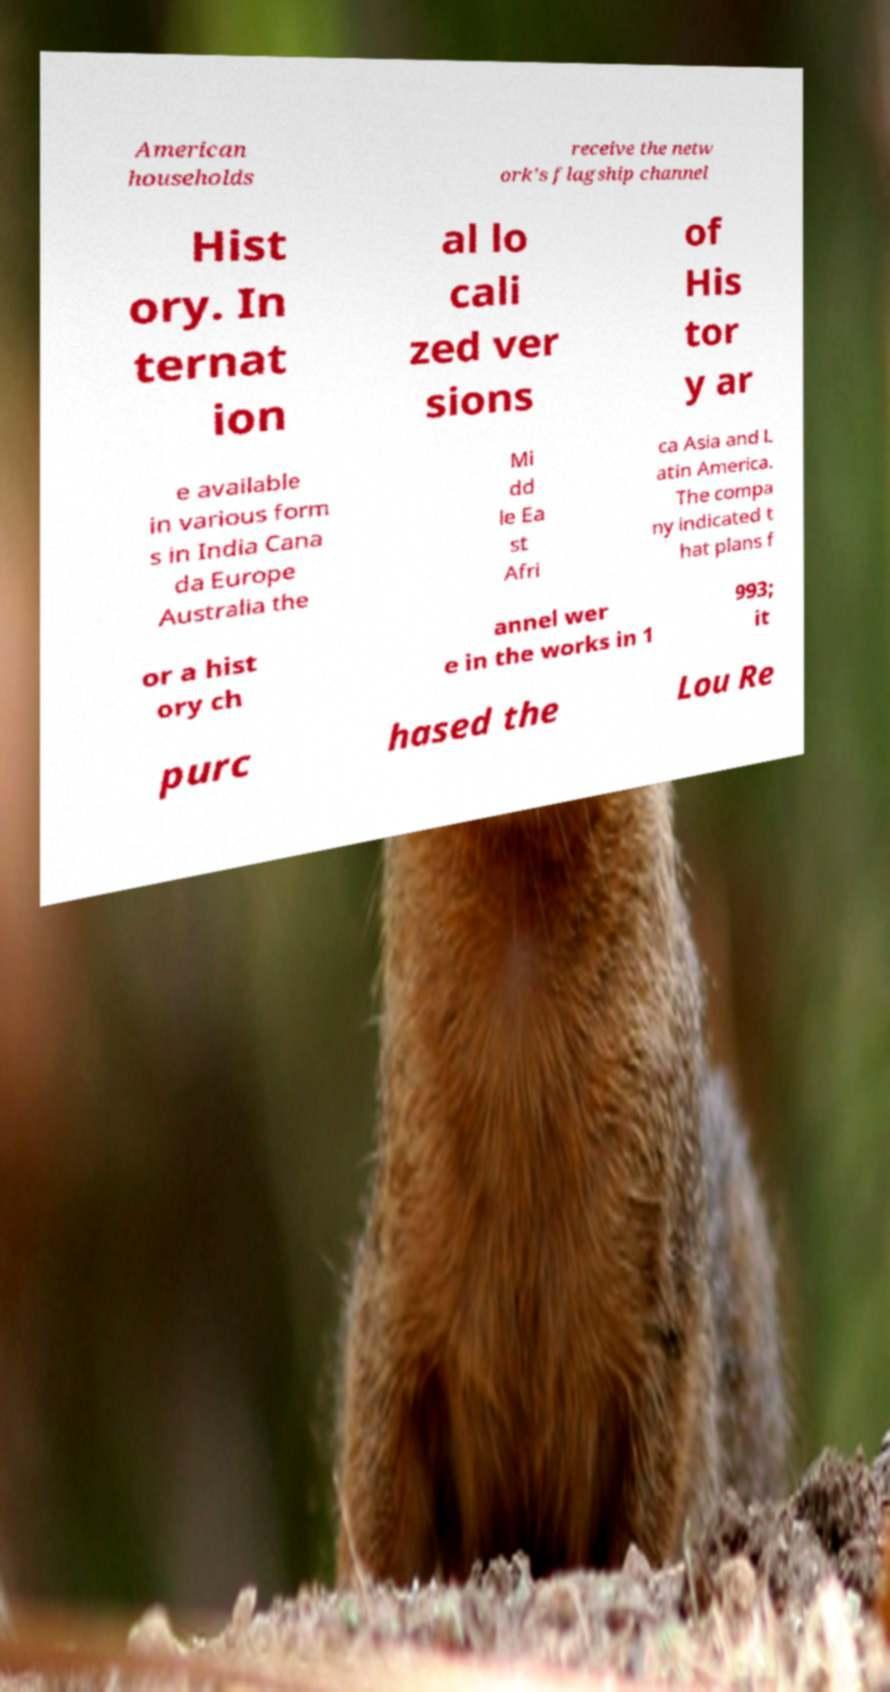Please identify and transcribe the text found in this image. American households receive the netw ork's flagship channel Hist ory. In ternat ion al lo cali zed ver sions of His tor y ar e available in various form s in India Cana da Europe Australia the Mi dd le Ea st Afri ca Asia and L atin America. The compa ny indicated t hat plans f or a hist ory ch annel wer e in the works in 1 993; it purc hased the Lou Re 